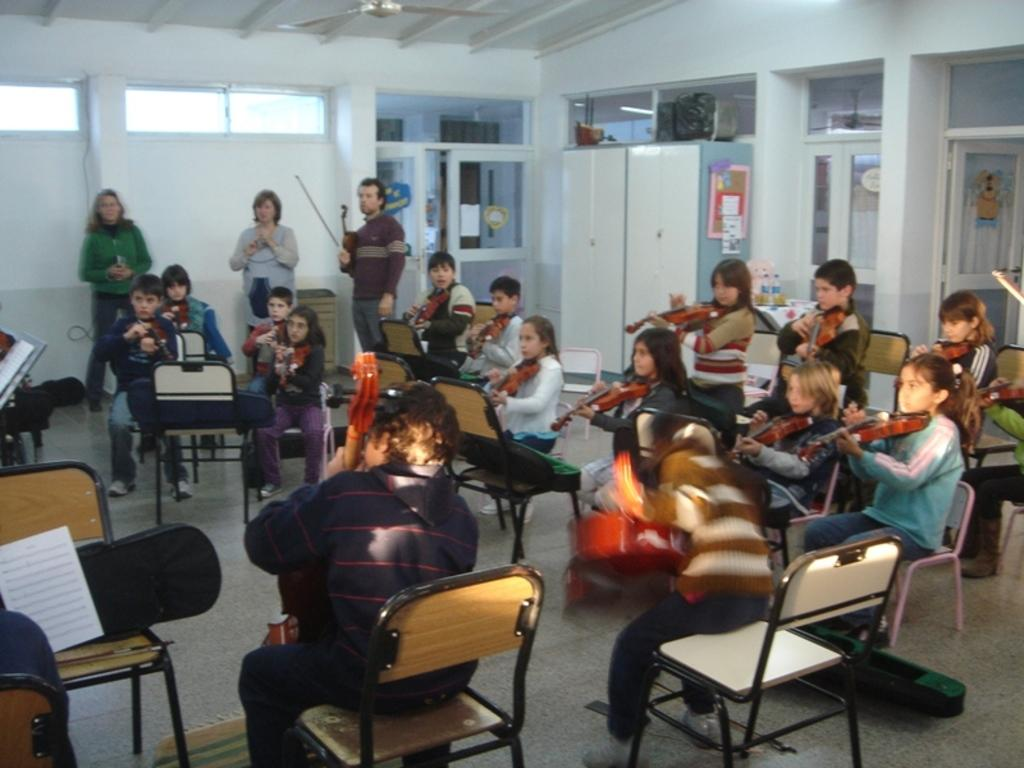What is happening in the image involving the group of children? The children are sitting and playing guitar in the image. Can you describe the people in the background of the image? There are two women and one man standing in the background of the image. What type of structures can be seen in the image? There is a wall, a window, and a door visible in the image. What type of lace is being used to decorate the guitar in the image? There is no lace visible on the guitar in the image. Is there a battle taking place in the image? No, there is no battle depicted in the image. 